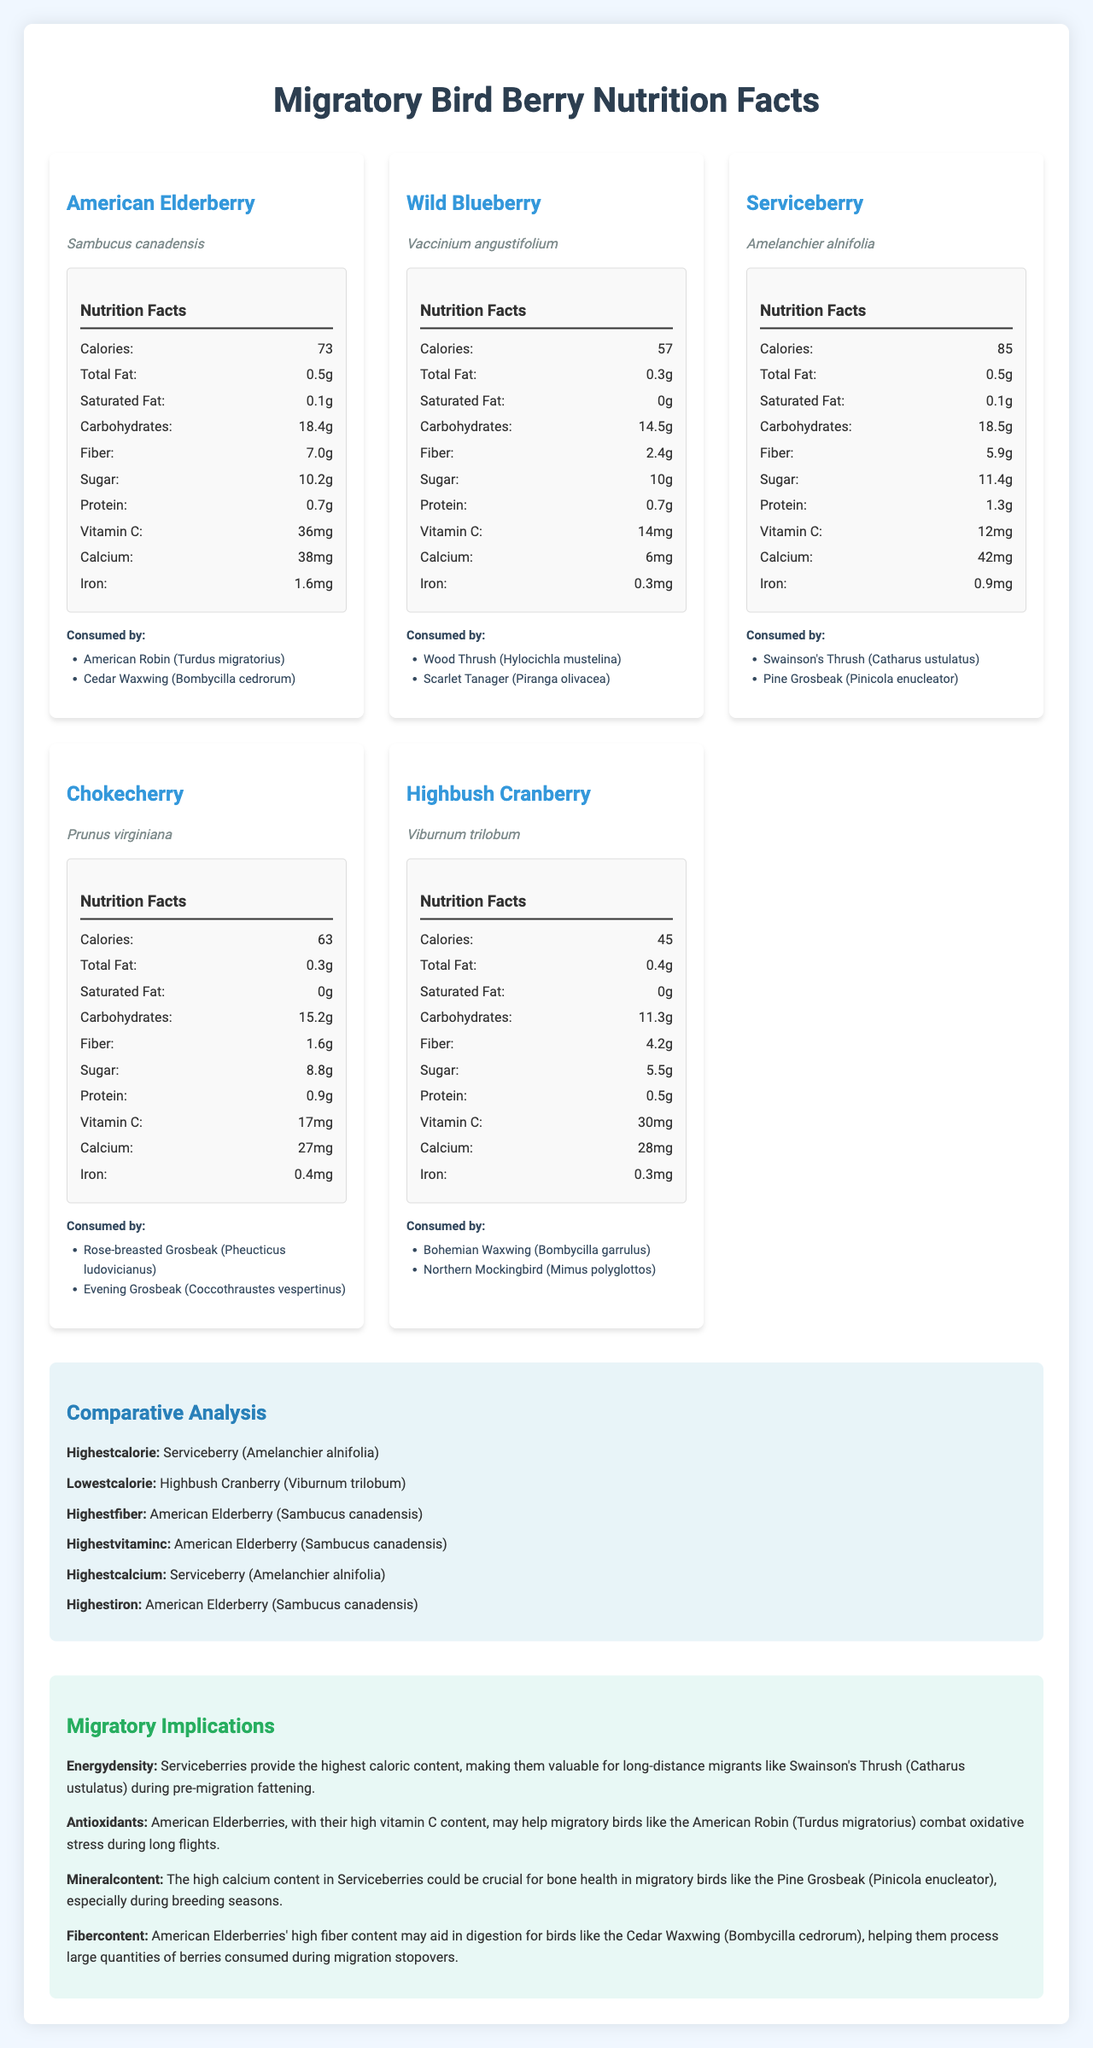what is the caloric content of wild blueberries per 100g? According to the nutrition facts for Wild Blueberry (Vaccinium angustifolium), the caloric content per 100g is 57 calories.
Answer: 57 calories which berry has the highest fiber content? The comparative analysis indicates that American Elderberry has the highest fiber content.
Answer: American Elderberry (Sambucus canadensis) how much vitamin C do Highbush Cranberries contain per 100g? The nutrition facts for Highbush Cranberries (Viburnum trilobum) show that they contain 30 mg of vitamin C per 100g.
Answer: 30 mg which migratory bird species consumes chokecherries? The document states that Chokecherry (Prunus virginiana) is consumed by Rose-breasted Grosbeak and Evening Grosbeak.
Answer: Rose-breasted Grosbeak (Pheucticus ludovicianus), Evening Grosbeak (Coccothraustes vespertinus) what is the protein content of serviceberries per 100g? The nutrition facts for Serviceberry (Amelanchier alnifolia) indicate a protein content of 1.3g per 100g.
Answer: 1.3 g which berry type is consumed by the American Robin (Turdus migratorius)? A. Chokecherry B. Wild Blueberry C. American Elderberry D. Highbush Cranberry The document lists the American Elderberry (Sambucus canadensis) as being consumed by the American Robin.
Answer: C which of the following has the lowest caloric content? I. American Elderberry II. Wild Blueberry III. Highbush Cranberry IV. Serviceberry The comparative analysis mentions that Highbush Cranberry (Viburnum trilobum) has the lowest caloric content.
Answer: III do highbush cranberries have a higher calcium content than chokecherries? Highbush Cranberry contains 28 mg of calcium, while Chokecherry contains 27 mg of calcium per 100g.
Answer: Yes summarize the main nutritional benefits of berries consumed by migratory birds. The document offers detailed nutritional content for various berries and their consumption by specific migratory birds. It highlights the highest nutrient values in each category and provides implications on how these nutrients benefit the birds during their migration.
Answer: The berries provide essential nutrients such as calories, fiber, vitamin C, calcium, and iron. They're crucial for different aspects of migratory birds' health, including energy for long flights, antioxidant protection, and bone health. which berry has the highest iron content? The comparative analysis section shows that American Elderberry has the highest iron content among the berries listed.
Answer: American Elderberry (Sambucus canadensis) what is the saturation fat content of the chokecherry per 100g? The nutrition facts for Chokecherry (Prunus virginiana) indicates that it contains 0g of saturated fat per 100g.
Answer: 0g which berry is especially valuable for long-distance migrants like Swainson's Thrush? The migratory implications section notes that Serviceberry, with its high caloric content, is valuable for long-distance migrants like the Swainson's Thrush.
Answer: Serviceberry (Amelanchier alnifolia) what kind of berry is only consumed by grosbeaks? The document does not provide exclusive detail about berries consumed only by grosbeaks among multiple types.
Answer: Not enough information 